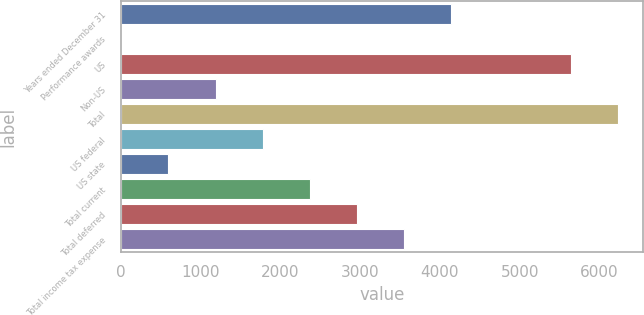Convert chart to OTSL. <chart><loc_0><loc_0><loc_500><loc_500><bar_chart><fcel>Years ended December 31<fcel>Performance awards<fcel>US<fcel>Non-US<fcel>Total<fcel>US federal<fcel>US state<fcel>Total current<fcel>Total deferred<fcel>Total income tax expense<nl><fcel>4138.47<fcel>4.9<fcel>5647<fcel>1185.92<fcel>6237.51<fcel>1776.43<fcel>595.41<fcel>2366.94<fcel>2957.45<fcel>3547.96<nl></chart> 